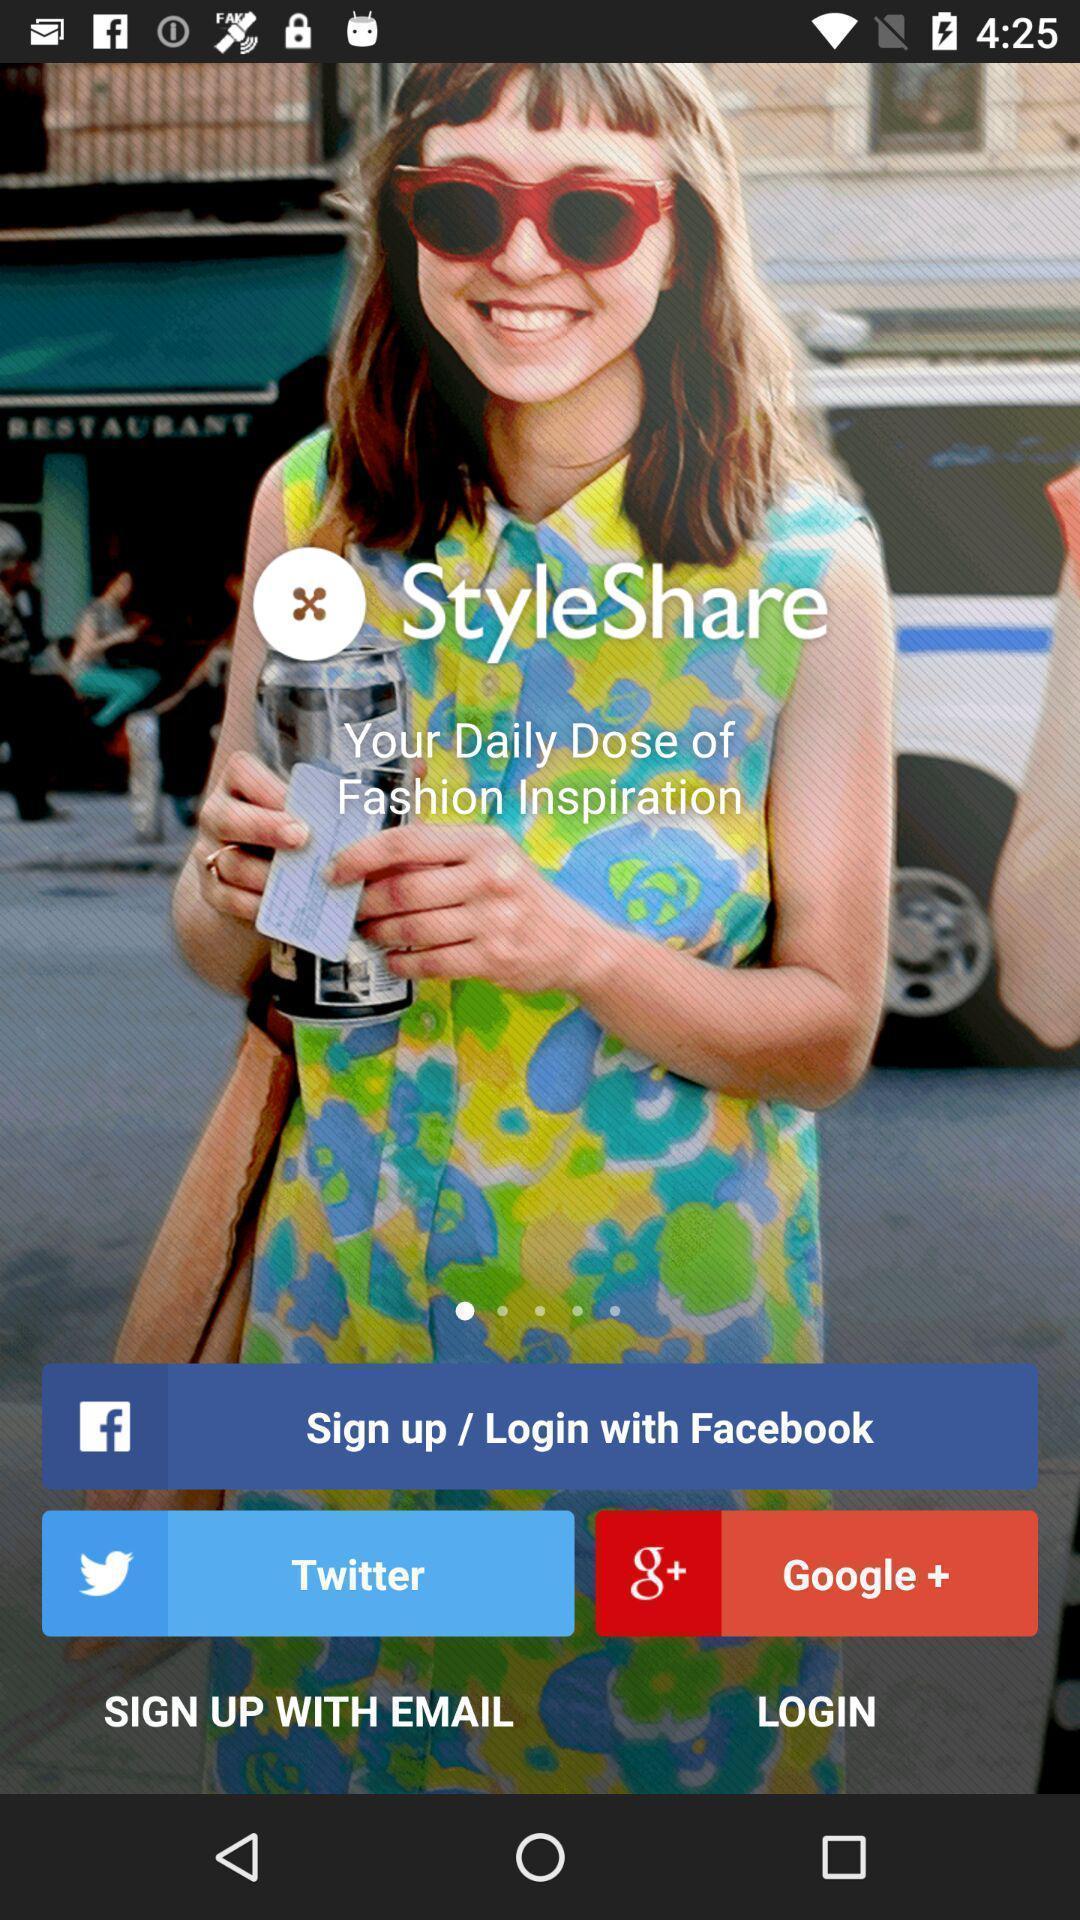What can you discern from this picture? Welcome page. 